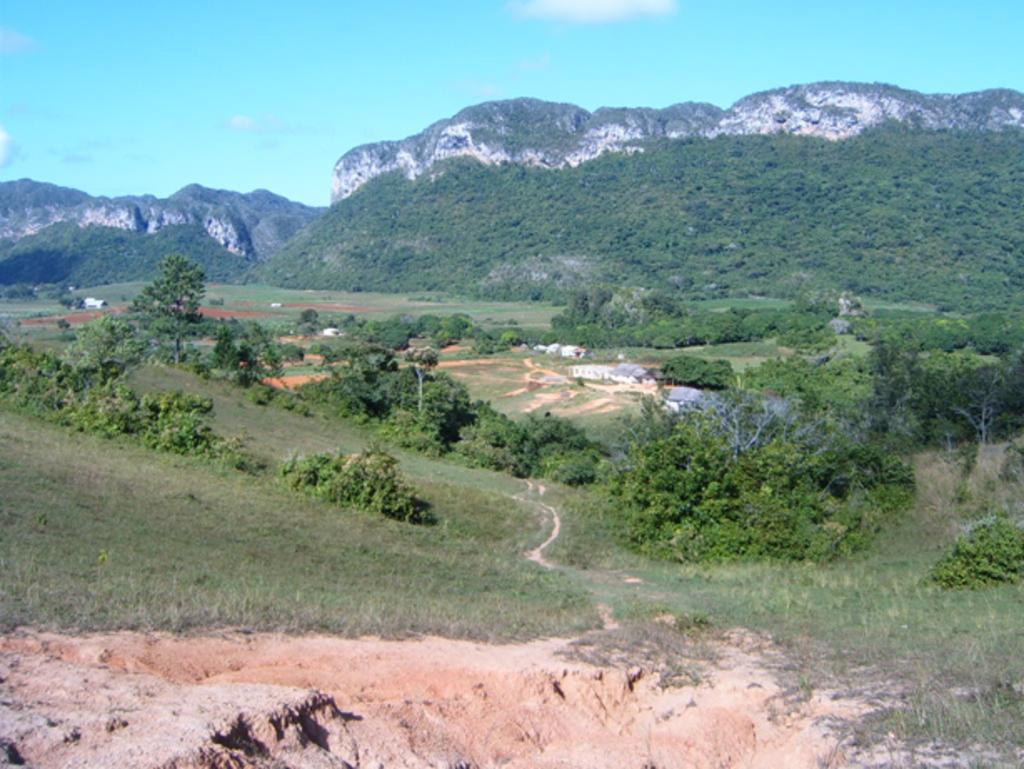Can you describe this image briefly? In the background we can see the sky, hills and the thicket. In this picture we can see the trees, ground and the green grass. 